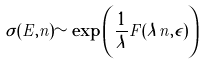Convert formula to latex. <formula><loc_0><loc_0><loc_500><loc_500>\sigma ( E , n ) \sim \exp \left ( \frac { 1 } { \lambda } F ( \lambda n , \epsilon ) \right )</formula> 